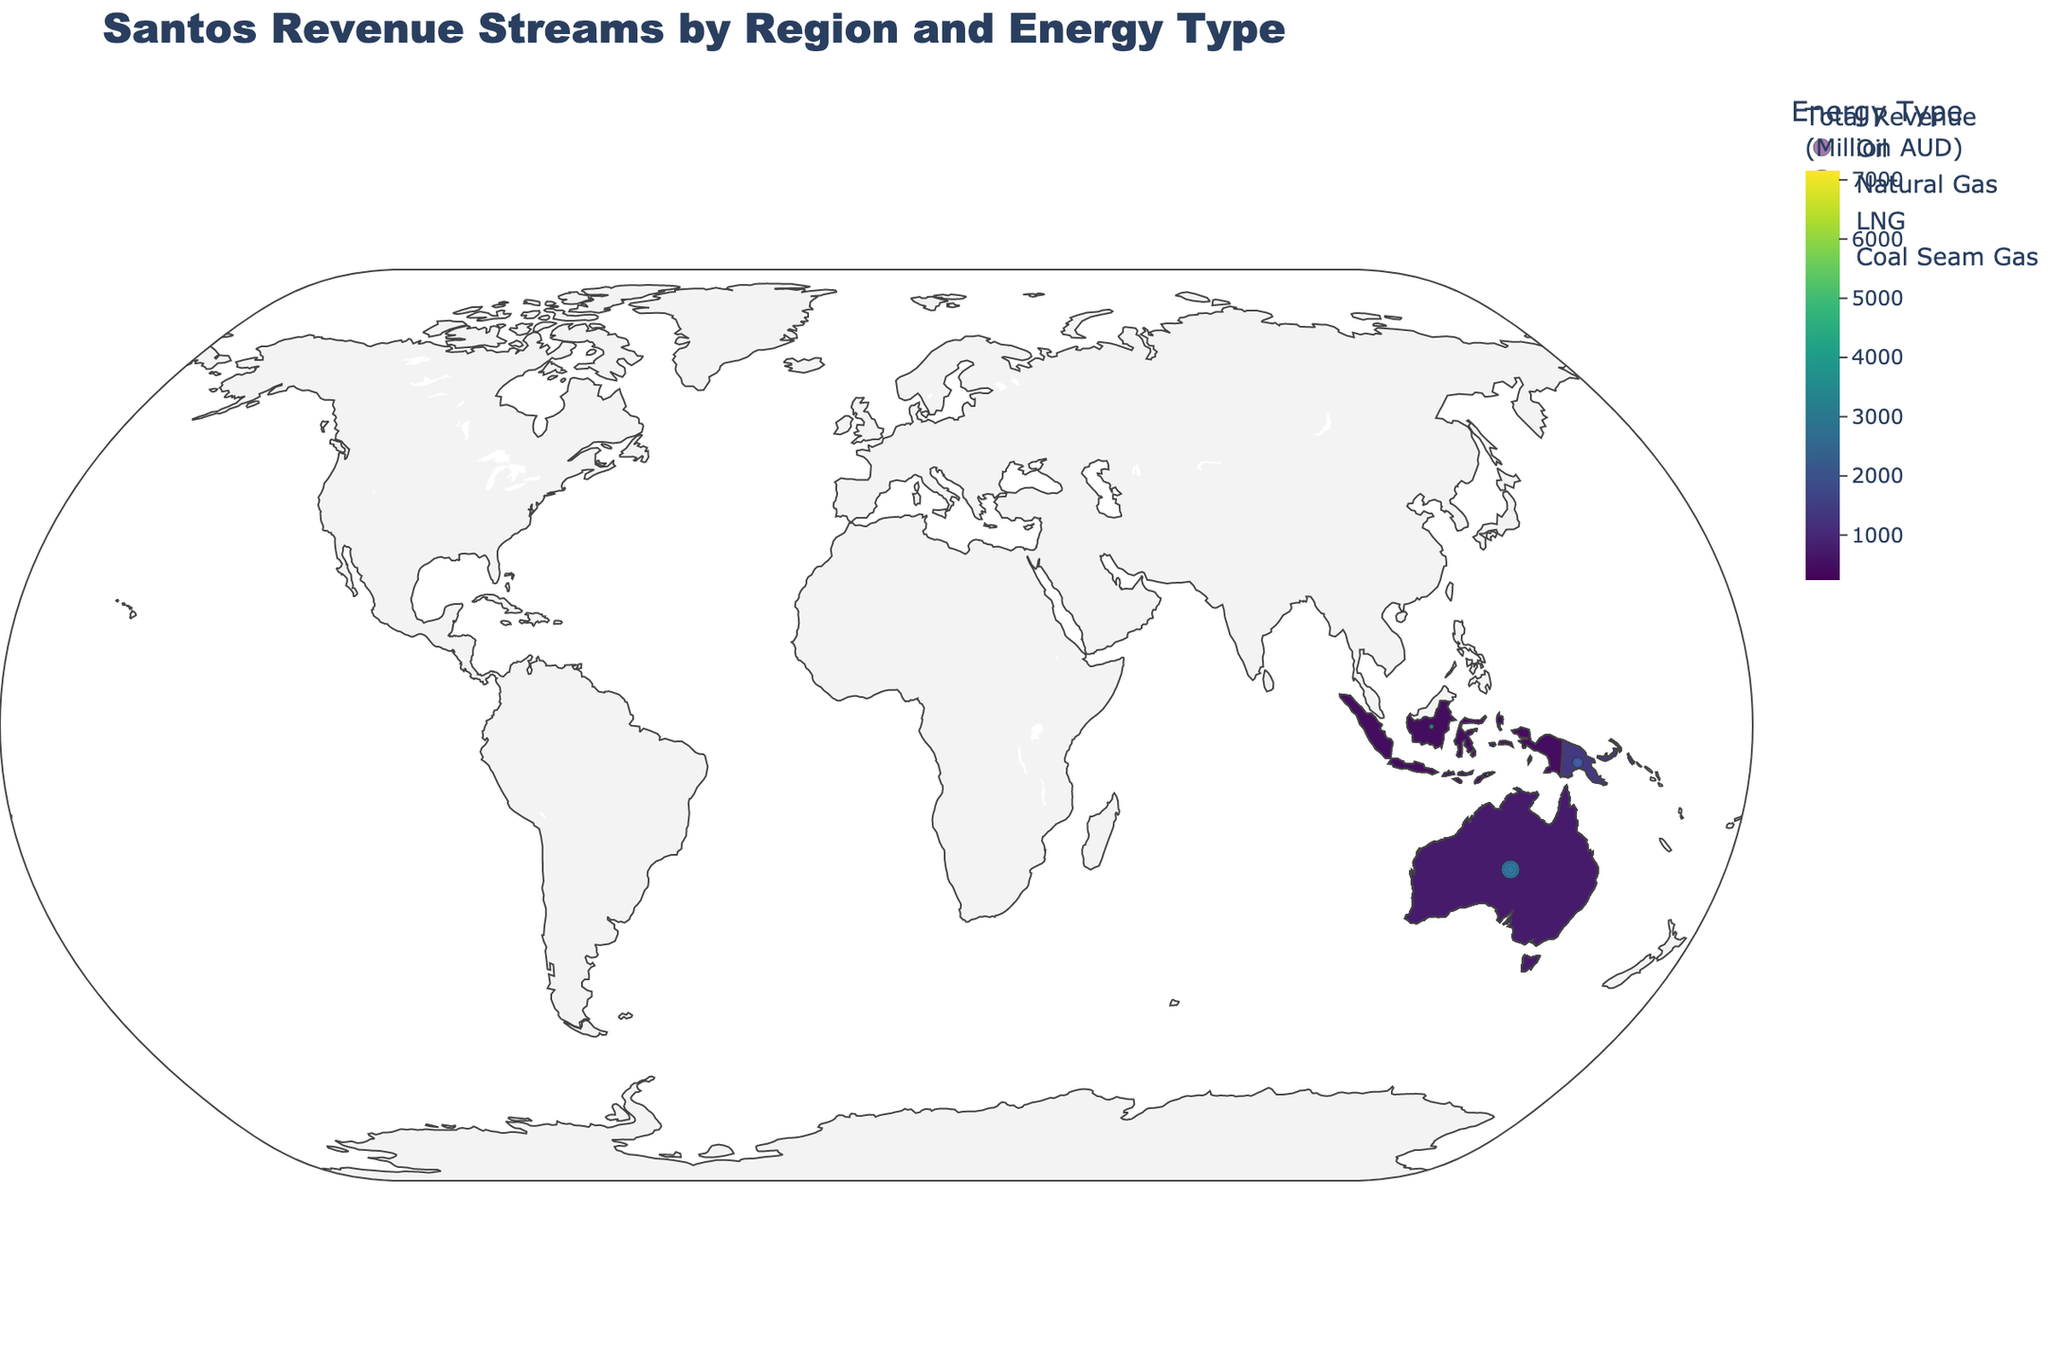what is the main energy type contributing to Santos' revenue in Australia? By observing the size and number of bubbles over Australia, it's clear that LNG has the largest contribution.
Answer: LNG Which region contributes the most to Santos' overall revenue? By analyzing the color intensity on the map, Australia has the darkest shade, indicating it has the highest total revenue.
Answer: Australia How does the revenue from oil in Papua New Guinea compare to that in Western Australia? By comparing the bubble sizes for oil in both regions, Papua New Guinea has a smaller bubble (420 M AUD) than Western Australia (580 M AUD).
Answer: Smaller What is the total revenue from oil across all regions? Sum up the revenue for oil from each region: Australia (1250) + PNG (420) + WA (580) + SA (310) + Indonesia (280) + Timor-Leste (150) = 2990 M AUD.
Answer: 2990 M AUD Which region has the least revenue from natural gas? By comparing the sizes of bubbles for natural gas in different regions, Timor-Leste has the smallest bubble (90 M AUD).
Answer: Timor-Leste Compare the revenue from coal seam gas in Queensland to LNG in Papua New Guinea. By comparing the bubble sizes, Queensland has 890 M AUD from coal seam gas, and PNG has 980 M AUD from LNG.
Answer: Coal seam gas revenue in Queensland is less What proportion of Australia's revenue comes from natural gas? Australia's natural gas revenue is 2800 M AUD, and total revenue from Australia is 1250 + 2800 + 3100 = 7150 M AUD. So, the proportion is 2800 / 7150 ≈ 0.391 (or 39.1%).
Answer: 39.1% What region has the highest revenue from a single energy type? According to the bubble sizes, Australia has the highest revenue from LNG at 3100 M AUD.
Answer: Australia with LNG Is South Australia's revenue mainly from oil or natural gas? The bubble for natural gas in South Australia (450 M AUD) is larger than for oil (310 M AUD).
Answer: Natural gas 